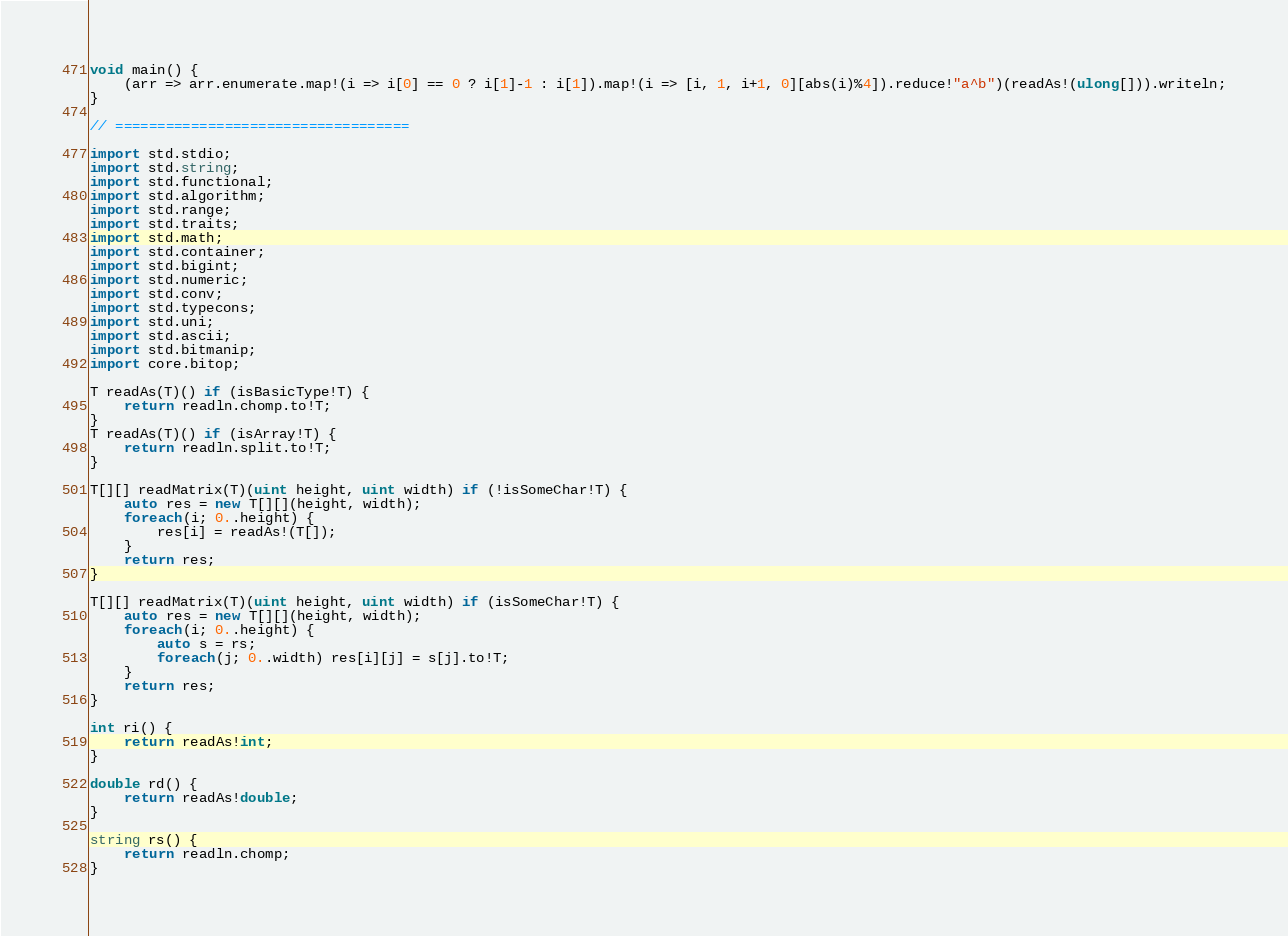Convert code to text. <code><loc_0><loc_0><loc_500><loc_500><_D_>void main() {
	(arr => arr.enumerate.map!(i => i[0] == 0 ? i[1]-1 : i[1]).map!(i => [i, 1, i+1, 0][abs(i)%4]).reduce!"a^b")(readAs!(ulong[])).writeln;
}

// ===================================

import std.stdio;
import std.string;
import std.functional;
import std.algorithm;
import std.range;
import std.traits;
import std.math;
import std.container;
import std.bigint;
import std.numeric;
import std.conv;
import std.typecons;
import std.uni;
import std.ascii;
import std.bitmanip;
import core.bitop;

T readAs(T)() if (isBasicType!T) {
	return readln.chomp.to!T;
}
T readAs(T)() if (isArray!T) {
	return readln.split.to!T;
}

T[][] readMatrix(T)(uint height, uint width) if (!isSomeChar!T) {
	auto res = new T[][](height, width);
	foreach(i; 0..height) {
		res[i] = readAs!(T[]);
	}
	return res;
}

T[][] readMatrix(T)(uint height, uint width) if (isSomeChar!T) {
	auto res = new T[][](height, width);
	foreach(i; 0..height) {
		auto s = rs;
		foreach(j; 0..width) res[i][j] = s[j].to!T;
	}
	return res;
}

int ri() {
	return readAs!int;
}

double rd() {
	return readAs!double;
}

string rs() {
	return readln.chomp;
}
</code> 